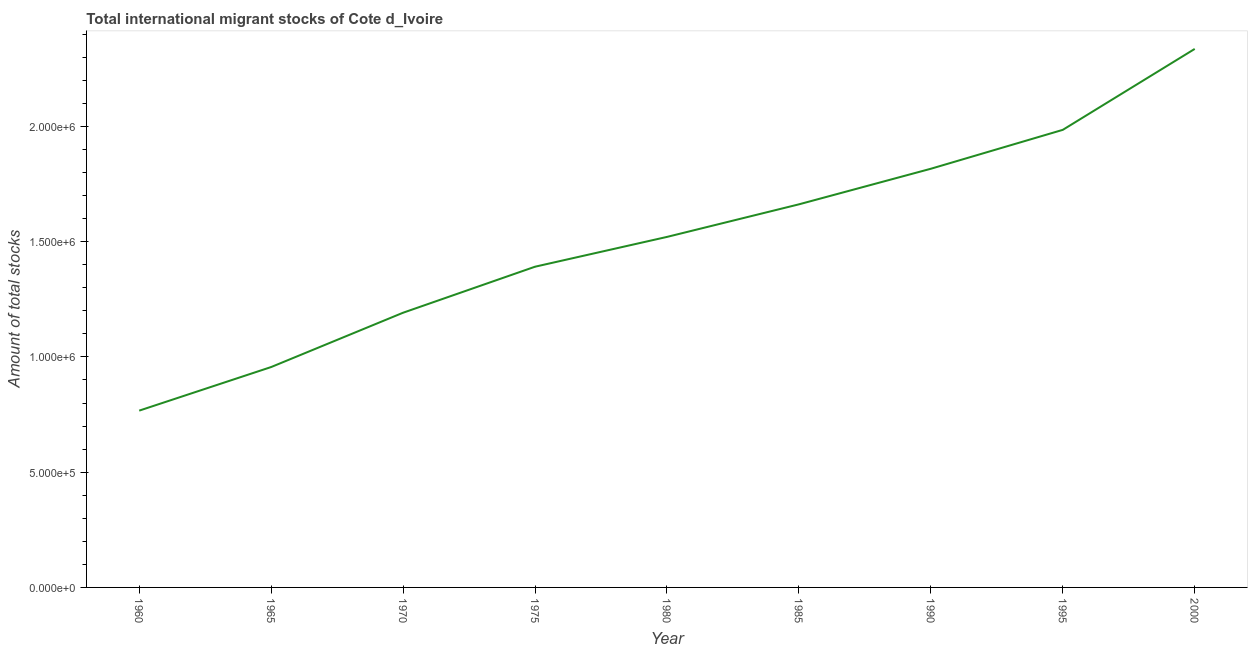What is the total number of international migrant stock in 1980?
Your response must be concise. 1.52e+06. Across all years, what is the maximum total number of international migrant stock?
Ensure brevity in your answer.  2.34e+06. Across all years, what is the minimum total number of international migrant stock?
Make the answer very short. 7.67e+05. What is the sum of the total number of international migrant stock?
Keep it short and to the point. 1.36e+07. What is the difference between the total number of international migrant stock in 1960 and 1985?
Your answer should be very brief. -8.95e+05. What is the average total number of international migrant stock per year?
Offer a terse response. 1.51e+06. What is the median total number of international migrant stock?
Provide a succinct answer. 1.52e+06. In how many years, is the total number of international migrant stock greater than 400000 ?
Your answer should be very brief. 9. Do a majority of the years between 1960 and 1985 (inclusive) have total number of international migrant stock greater than 1600000 ?
Keep it short and to the point. No. What is the ratio of the total number of international migrant stock in 1970 to that in 1985?
Offer a terse response. 0.72. Is the difference between the total number of international migrant stock in 1960 and 1970 greater than the difference between any two years?
Ensure brevity in your answer.  No. What is the difference between the highest and the second highest total number of international migrant stock?
Make the answer very short. 3.51e+05. Is the sum of the total number of international migrant stock in 1975 and 1995 greater than the maximum total number of international migrant stock across all years?
Your answer should be compact. Yes. What is the difference between the highest and the lowest total number of international migrant stock?
Your answer should be compact. 1.57e+06. In how many years, is the total number of international migrant stock greater than the average total number of international migrant stock taken over all years?
Ensure brevity in your answer.  5. Does the total number of international migrant stock monotonically increase over the years?
Your answer should be compact. Yes. What is the difference between two consecutive major ticks on the Y-axis?
Make the answer very short. 5.00e+05. Are the values on the major ticks of Y-axis written in scientific E-notation?
Offer a terse response. Yes. Does the graph contain grids?
Ensure brevity in your answer.  No. What is the title of the graph?
Offer a very short reply. Total international migrant stocks of Cote d_Ivoire. What is the label or title of the X-axis?
Keep it short and to the point. Year. What is the label or title of the Y-axis?
Offer a very short reply. Amount of total stocks. What is the Amount of total stocks of 1960?
Provide a succinct answer. 7.67e+05. What is the Amount of total stocks of 1965?
Give a very brief answer. 9.56e+05. What is the Amount of total stocks of 1970?
Your response must be concise. 1.19e+06. What is the Amount of total stocks of 1975?
Your response must be concise. 1.39e+06. What is the Amount of total stocks of 1980?
Your response must be concise. 1.52e+06. What is the Amount of total stocks of 1985?
Offer a terse response. 1.66e+06. What is the Amount of total stocks in 1990?
Your response must be concise. 1.82e+06. What is the Amount of total stocks of 1995?
Keep it short and to the point. 1.99e+06. What is the Amount of total stocks of 2000?
Make the answer very short. 2.34e+06. What is the difference between the Amount of total stocks in 1960 and 1965?
Give a very brief answer. -1.89e+05. What is the difference between the Amount of total stocks in 1960 and 1970?
Keep it short and to the point. -4.25e+05. What is the difference between the Amount of total stocks in 1960 and 1975?
Make the answer very short. -6.24e+05. What is the difference between the Amount of total stocks in 1960 and 1980?
Provide a short and direct response. -7.54e+05. What is the difference between the Amount of total stocks in 1960 and 1985?
Keep it short and to the point. -8.95e+05. What is the difference between the Amount of total stocks in 1960 and 1990?
Ensure brevity in your answer.  -1.05e+06. What is the difference between the Amount of total stocks in 1960 and 1995?
Offer a very short reply. -1.22e+06. What is the difference between the Amount of total stocks in 1960 and 2000?
Provide a short and direct response. -1.57e+06. What is the difference between the Amount of total stocks in 1965 and 1970?
Offer a very short reply. -2.36e+05. What is the difference between the Amount of total stocks in 1965 and 1975?
Offer a very short reply. -4.35e+05. What is the difference between the Amount of total stocks in 1965 and 1980?
Ensure brevity in your answer.  -5.65e+05. What is the difference between the Amount of total stocks in 1965 and 1985?
Give a very brief answer. -7.06e+05. What is the difference between the Amount of total stocks in 1965 and 1990?
Your answer should be compact. -8.60e+05. What is the difference between the Amount of total stocks in 1965 and 1995?
Offer a terse response. -1.03e+06. What is the difference between the Amount of total stocks in 1965 and 2000?
Provide a succinct answer. -1.38e+06. What is the difference between the Amount of total stocks in 1970 and 1975?
Offer a terse response. -2.00e+05. What is the difference between the Amount of total stocks in 1970 and 1980?
Your answer should be compact. -3.29e+05. What is the difference between the Amount of total stocks in 1970 and 1985?
Your answer should be compact. -4.70e+05. What is the difference between the Amount of total stocks in 1970 and 1990?
Provide a short and direct response. -6.25e+05. What is the difference between the Amount of total stocks in 1970 and 1995?
Offer a terse response. -7.93e+05. What is the difference between the Amount of total stocks in 1970 and 2000?
Give a very brief answer. -1.14e+06. What is the difference between the Amount of total stocks in 1975 and 1980?
Your answer should be compact. -1.29e+05. What is the difference between the Amount of total stocks in 1975 and 1985?
Give a very brief answer. -2.71e+05. What is the difference between the Amount of total stocks in 1975 and 1990?
Your answer should be compact. -4.25e+05. What is the difference between the Amount of total stocks in 1975 and 1995?
Your response must be concise. -5.94e+05. What is the difference between the Amount of total stocks in 1975 and 2000?
Make the answer very short. -9.45e+05. What is the difference between the Amount of total stocks in 1980 and 1985?
Provide a succinct answer. -1.41e+05. What is the difference between the Amount of total stocks in 1980 and 1990?
Keep it short and to the point. -2.96e+05. What is the difference between the Amount of total stocks in 1980 and 1995?
Ensure brevity in your answer.  -4.65e+05. What is the difference between the Amount of total stocks in 1980 and 2000?
Offer a very short reply. -8.16e+05. What is the difference between the Amount of total stocks in 1985 and 1990?
Your answer should be compact. -1.54e+05. What is the difference between the Amount of total stocks in 1985 and 1995?
Keep it short and to the point. -3.23e+05. What is the difference between the Amount of total stocks in 1985 and 2000?
Provide a short and direct response. -6.74e+05. What is the difference between the Amount of total stocks in 1990 and 1995?
Your response must be concise. -1.69e+05. What is the difference between the Amount of total stocks in 1990 and 2000?
Offer a very short reply. -5.20e+05. What is the difference between the Amount of total stocks in 1995 and 2000?
Make the answer very short. -3.51e+05. What is the ratio of the Amount of total stocks in 1960 to that in 1965?
Offer a terse response. 0.8. What is the ratio of the Amount of total stocks in 1960 to that in 1970?
Provide a short and direct response. 0.64. What is the ratio of the Amount of total stocks in 1960 to that in 1975?
Keep it short and to the point. 0.55. What is the ratio of the Amount of total stocks in 1960 to that in 1980?
Provide a succinct answer. 0.5. What is the ratio of the Amount of total stocks in 1960 to that in 1985?
Ensure brevity in your answer.  0.46. What is the ratio of the Amount of total stocks in 1960 to that in 1990?
Ensure brevity in your answer.  0.42. What is the ratio of the Amount of total stocks in 1960 to that in 1995?
Your answer should be compact. 0.39. What is the ratio of the Amount of total stocks in 1960 to that in 2000?
Your response must be concise. 0.33. What is the ratio of the Amount of total stocks in 1965 to that in 1970?
Make the answer very short. 0.8. What is the ratio of the Amount of total stocks in 1965 to that in 1975?
Provide a succinct answer. 0.69. What is the ratio of the Amount of total stocks in 1965 to that in 1980?
Give a very brief answer. 0.63. What is the ratio of the Amount of total stocks in 1965 to that in 1985?
Give a very brief answer. 0.57. What is the ratio of the Amount of total stocks in 1965 to that in 1990?
Offer a very short reply. 0.53. What is the ratio of the Amount of total stocks in 1965 to that in 1995?
Your response must be concise. 0.48. What is the ratio of the Amount of total stocks in 1965 to that in 2000?
Offer a terse response. 0.41. What is the ratio of the Amount of total stocks in 1970 to that in 1975?
Your answer should be compact. 0.86. What is the ratio of the Amount of total stocks in 1970 to that in 1980?
Offer a very short reply. 0.78. What is the ratio of the Amount of total stocks in 1970 to that in 1985?
Your answer should be very brief. 0.72. What is the ratio of the Amount of total stocks in 1970 to that in 1990?
Offer a very short reply. 0.66. What is the ratio of the Amount of total stocks in 1970 to that in 2000?
Provide a short and direct response. 0.51. What is the ratio of the Amount of total stocks in 1975 to that in 1980?
Ensure brevity in your answer.  0.92. What is the ratio of the Amount of total stocks in 1975 to that in 1985?
Make the answer very short. 0.84. What is the ratio of the Amount of total stocks in 1975 to that in 1990?
Your answer should be compact. 0.77. What is the ratio of the Amount of total stocks in 1975 to that in 1995?
Give a very brief answer. 0.7. What is the ratio of the Amount of total stocks in 1975 to that in 2000?
Provide a short and direct response. 0.6. What is the ratio of the Amount of total stocks in 1980 to that in 1985?
Provide a short and direct response. 0.92. What is the ratio of the Amount of total stocks in 1980 to that in 1990?
Your answer should be compact. 0.84. What is the ratio of the Amount of total stocks in 1980 to that in 1995?
Your answer should be very brief. 0.77. What is the ratio of the Amount of total stocks in 1980 to that in 2000?
Keep it short and to the point. 0.65. What is the ratio of the Amount of total stocks in 1985 to that in 1990?
Provide a short and direct response. 0.92. What is the ratio of the Amount of total stocks in 1985 to that in 1995?
Make the answer very short. 0.84. What is the ratio of the Amount of total stocks in 1985 to that in 2000?
Provide a succinct answer. 0.71. What is the ratio of the Amount of total stocks in 1990 to that in 1995?
Offer a terse response. 0.92. What is the ratio of the Amount of total stocks in 1990 to that in 2000?
Offer a very short reply. 0.78. 